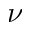Convert formula to latex. <formula><loc_0><loc_0><loc_500><loc_500>\nu</formula> 